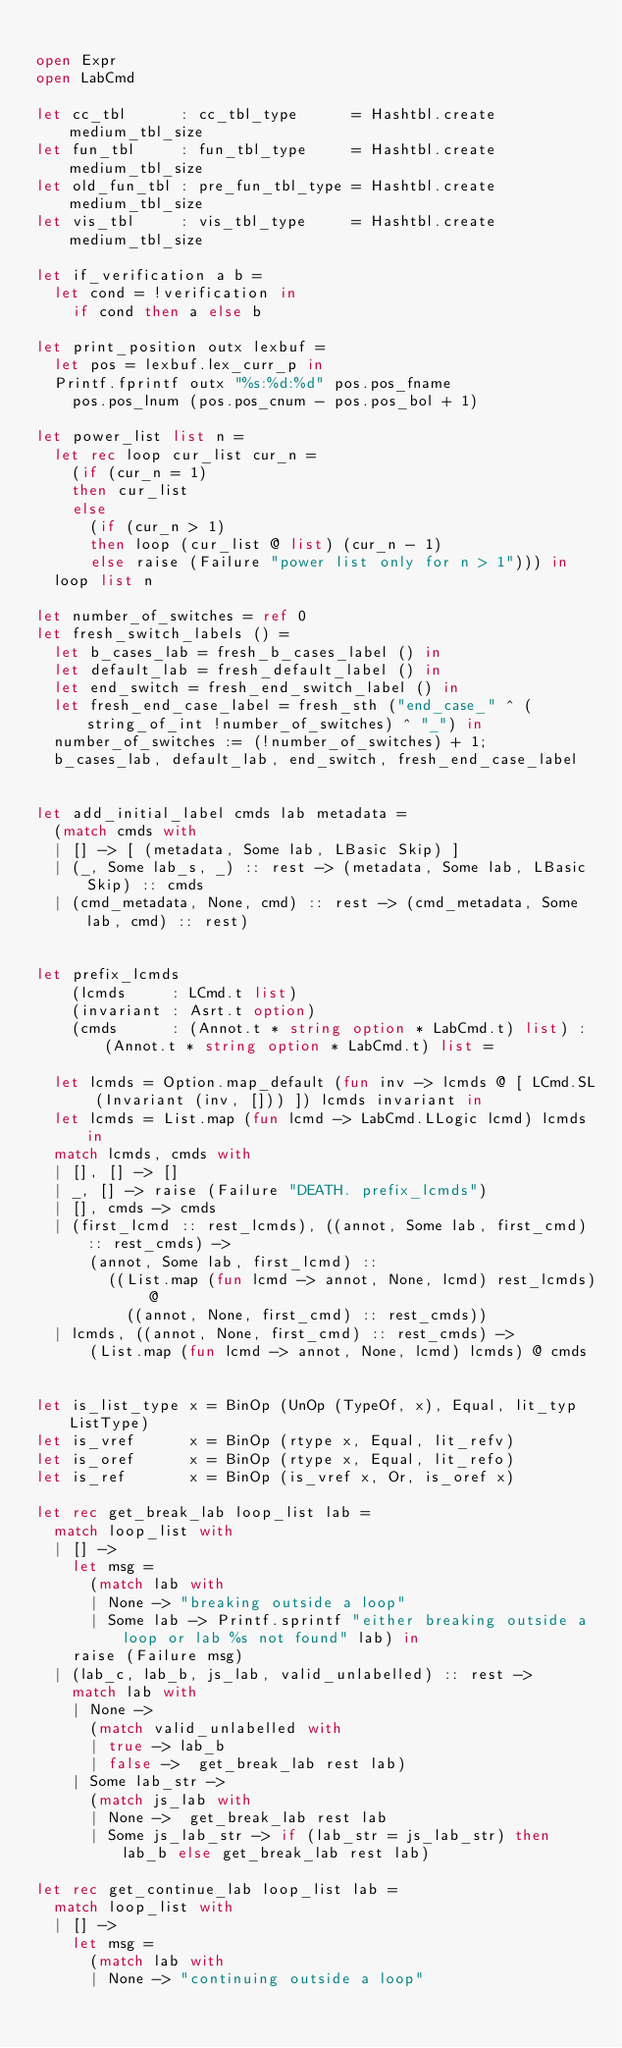<code> <loc_0><loc_0><loc_500><loc_500><_OCaml_>
open Expr
open LabCmd

let cc_tbl      : cc_tbl_type      = Hashtbl.create medium_tbl_size
let fun_tbl     : fun_tbl_type     = Hashtbl.create medium_tbl_size
let old_fun_tbl : pre_fun_tbl_type = Hashtbl.create medium_tbl_size
let vis_tbl     : vis_tbl_type     = Hashtbl.create medium_tbl_size

let if_verification a b = 
  let cond = !verification in
    if cond then a else b
    
let print_position outx lexbuf =
  let pos = lexbuf.lex_curr_p in
  Printf.fprintf outx "%s:%d:%d" pos.pos_fname
    pos.pos_lnum (pos.pos_cnum - pos.pos_bol + 1)

let power_list list n =
  let rec loop cur_list cur_n =
    (if (cur_n = 1)
    then cur_list
    else
      (if (cur_n > 1)
      then loop (cur_list @ list) (cur_n - 1)
      else raise (Failure "power list only for n > 1"))) in
  loop list n

let number_of_switches = ref 0
let fresh_switch_labels () =
  let b_cases_lab = fresh_b_cases_label () in
  let default_lab = fresh_default_label () in
  let end_switch = fresh_end_switch_label () in
  let fresh_end_case_label = fresh_sth ("end_case_" ^ (string_of_int !number_of_switches) ^ "_") in
  number_of_switches := (!number_of_switches) + 1;
  b_cases_lab, default_lab, end_switch, fresh_end_case_label


let add_initial_label cmds lab metadata =
  (match cmds with
  | [] -> [ (metadata, Some lab, LBasic Skip) ]
  | (_, Some lab_s, _) :: rest -> (metadata, Some lab, LBasic Skip) :: cmds
  | (cmd_metadata, None, cmd) :: rest -> (cmd_metadata, Some lab, cmd) :: rest)


let prefix_lcmds  
    (lcmds     : LCmd.t list) 
    (invariant : Asrt.t option) 
    (cmds      : (Annot.t * string option * LabCmd.t) list) : (Annot.t * string option * LabCmd.t) list =

  let lcmds = Option.map_default (fun inv -> lcmds @ [ LCmd.SL (Invariant (inv, [])) ]) lcmds invariant in  
  let lcmds = List.map (fun lcmd -> LabCmd.LLogic lcmd) lcmds in  
  match lcmds, cmds with 
  | [], [] -> []
  | _, [] -> raise (Failure "DEATH. prefix_lcmds")
  | [], cmds -> cmds 
  | (first_lcmd :: rest_lcmds), ((annot, Some lab, first_cmd) :: rest_cmds) -> 
      (annot, Some lab, first_lcmd) :: 
        ((List.map (fun lcmd -> annot, None, lcmd) rest_lcmds) @ 
          ((annot, None, first_cmd) :: rest_cmds))
  | lcmds, ((annot, None, first_cmd) :: rest_cmds) -> 
      (List.map (fun lcmd -> annot, None, lcmd) lcmds) @ cmds


let is_list_type x = BinOp (UnOp (TypeOf, x), Equal, lit_typ ListType)
let is_vref      x = BinOp (rtype x, Equal, lit_refv)
let is_oref      x = BinOp (rtype x, Equal, lit_refo)
let is_ref       x = BinOp (is_vref x, Or, is_oref x)

let rec get_break_lab loop_list lab =
  match loop_list with
  | [] ->
    let msg =
      (match lab with
      | None -> "breaking outside a loop"
      | Some lab -> Printf.sprintf "either breaking outside a loop or lab %s not found" lab) in
    raise (Failure msg)
  | (lab_c, lab_b, js_lab, valid_unlabelled) :: rest ->
    match lab with
    | None ->
      (match valid_unlabelled with
      | true -> lab_b
      | false ->  get_break_lab rest lab)
    | Some lab_str ->
      (match js_lab with
      | None ->  get_break_lab rest lab
      | Some js_lab_str -> if (lab_str = js_lab_str) then lab_b else get_break_lab rest lab)

let rec get_continue_lab loop_list lab =
  match loop_list with
  | [] ->
    let msg =
      (match lab with
      | None -> "continuing outside a loop"</code> 